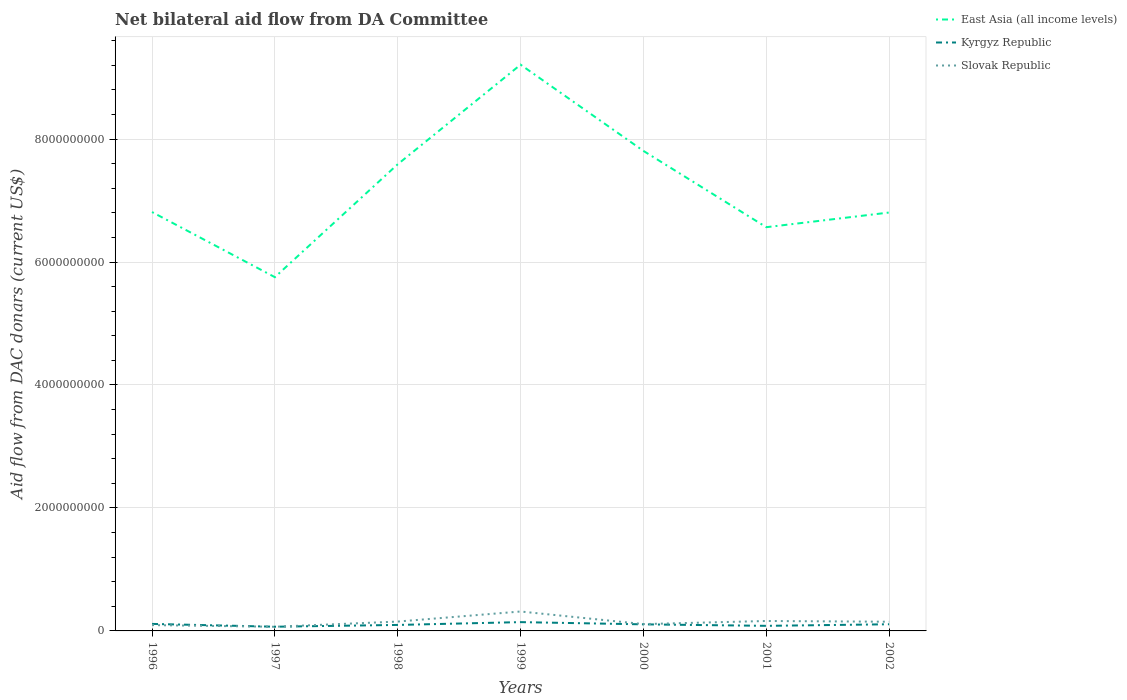How many different coloured lines are there?
Provide a succinct answer. 3. Does the line corresponding to East Asia (all income levels) intersect with the line corresponding to Slovak Republic?
Provide a short and direct response. No. Is the number of lines equal to the number of legend labels?
Your answer should be very brief. Yes. Across all years, what is the maximum aid flow in in East Asia (all income levels)?
Your answer should be very brief. 5.75e+09. In which year was the aid flow in in East Asia (all income levels) maximum?
Provide a succinct answer. 1997. What is the total aid flow in in East Asia (all income levels) in the graph?
Give a very brief answer. 1.06e+09. What is the difference between the highest and the second highest aid flow in in East Asia (all income levels)?
Your answer should be compact. 3.46e+09. Is the aid flow in in Kyrgyz Republic strictly greater than the aid flow in in Slovak Republic over the years?
Your answer should be very brief. No. What is the difference between two consecutive major ticks on the Y-axis?
Provide a succinct answer. 2.00e+09. Are the values on the major ticks of Y-axis written in scientific E-notation?
Offer a very short reply. No. Does the graph contain grids?
Offer a very short reply. Yes. How many legend labels are there?
Your response must be concise. 3. How are the legend labels stacked?
Your answer should be compact. Vertical. What is the title of the graph?
Ensure brevity in your answer.  Net bilateral aid flow from DA Committee. Does "Kyrgyz Republic" appear as one of the legend labels in the graph?
Your answer should be compact. Yes. What is the label or title of the X-axis?
Give a very brief answer. Years. What is the label or title of the Y-axis?
Make the answer very short. Aid flow from DAC donars (current US$). What is the Aid flow from DAC donars (current US$) in East Asia (all income levels) in 1996?
Make the answer very short. 6.81e+09. What is the Aid flow from DAC donars (current US$) in Kyrgyz Republic in 1996?
Offer a terse response. 1.14e+08. What is the Aid flow from DAC donars (current US$) of Slovak Republic in 1996?
Offer a terse response. 9.47e+07. What is the Aid flow from DAC donars (current US$) in East Asia (all income levels) in 1997?
Your answer should be compact. 5.75e+09. What is the Aid flow from DAC donars (current US$) in Kyrgyz Republic in 1997?
Make the answer very short. 6.83e+07. What is the Aid flow from DAC donars (current US$) of Slovak Republic in 1997?
Provide a succinct answer. 6.75e+07. What is the Aid flow from DAC donars (current US$) of East Asia (all income levels) in 1998?
Your answer should be very brief. 7.59e+09. What is the Aid flow from DAC donars (current US$) in Kyrgyz Republic in 1998?
Your answer should be very brief. 9.74e+07. What is the Aid flow from DAC donars (current US$) of Slovak Republic in 1998?
Make the answer very short. 1.52e+08. What is the Aid flow from DAC donars (current US$) in East Asia (all income levels) in 1999?
Provide a short and direct response. 9.21e+09. What is the Aid flow from DAC donars (current US$) of Kyrgyz Republic in 1999?
Provide a short and direct response. 1.43e+08. What is the Aid flow from DAC donars (current US$) of Slovak Republic in 1999?
Provide a short and direct response. 3.16e+08. What is the Aid flow from DAC donars (current US$) of East Asia (all income levels) in 2000?
Your answer should be very brief. 7.81e+09. What is the Aid flow from DAC donars (current US$) of Kyrgyz Republic in 2000?
Keep it short and to the point. 1.07e+08. What is the Aid flow from DAC donars (current US$) in Slovak Republic in 2000?
Your response must be concise. 1.11e+08. What is the Aid flow from DAC donars (current US$) in East Asia (all income levels) in 2001?
Provide a short and direct response. 6.57e+09. What is the Aid flow from DAC donars (current US$) in Kyrgyz Republic in 2001?
Your response must be concise. 8.27e+07. What is the Aid flow from DAC donars (current US$) of Slovak Republic in 2001?
Keep it short and to the point. 1.62e+08. What is the Aid flow from DAC donars (current US$) in East Asia (all income levels) in 2002?
Give a very brief answer. 6.80e+09. What is the Aid flow from DAC donars (current US$) of Kyrgyz Republic in 2002?
Make the answer very short. 1.08e+08. What is the Aid flow from DAC donars (current US$) of Slovak Republic in 2002?
Your response must be concise. 1.49e+08. Across all years, what is the maximum Aid flow from DAC donars (current US$) of East Asia (all income levels)?
Make the answer very short. 9.21e+09. Across all years, what is the maximum Aid flow from DAC donars (current US$) of Kyrgyz Republic?
Give a very brief answer. 1.43e+08. Across all years, what is the maximum Aid flow from DAC donars (current US$) in Slovak Republic?
Your answer should be very brief. 3.16e+08. Across all years, what is the minimum Aid flow from DAC donars (current US$) of East Asia (all income levels)?
Give a very brief answer. 5.75e+09. Across all years, what is the minimum Aid flow from DAC donars (current US$) in Kyrgyz Republic?
Offer a terse response. 6.83e+07. Across all years, what is the minimum Aid flow from DAC donars (current US$) of Slovak Republic?
Ensure brevity in your answer.  6.75e+07. What is the total Aid flow from DAC donars (current US$) in East Asia (all income levels) in the graph?
Give a very brief answer. 5.05e+1. What is the total Aid flow from DAC donars (current US$) in Kyrgyz Republic in the graph?
Give a very brief answer. 7.21e+08. What is the total Aid flow from DAC donars (current US$) in Slovak Republic in the graph?
Your answer should be compact. 1.05e+09. What is the difference between the Aid flow from DAC donars (current US$) of East Asia (all income levels) in 1996 and that in 1997?
Offer a terse response. 1.06e+09. What is the difference between the Aid flow from DAC donars (current US$) of Kyrgyz Republic in 1996 and that in 1997?
Offer a very short reply. 4.58e+07. What is the difference between the Aid flow from DAC donars (current US$) of Slovak Republic in 1996 and that in 1997?
Make the answer very short. 2.72e+07. What is the difference between the Aid flow from DAC donars (current US$) of East Asia (all income levels) in 1996 and that in 1998?
Offer a terse response. -7.77e+08. What is the difference between the Aid flow from DAC donars (current US$) of Kyrgyz Republic in 1996 and that in 1998?
Your answer should be very brief. 1.66e+07. What is the difference between the Aid flow from DAC donars (current US$) in Slovak Republic in 1996 and that in 1998?
Ensure brevity in your answer.  -5.76e+07. What is the difference between the Aid flow from DAC donars (current US$) of East Asia (all income levels) in 1996 and that in 1999?
Offer a very short reply. -2.40e+09. What is the difference between the Aid flow from DAC donars (current US$) in Kyrgyz Republic in 1996 and that in 1999?
Your response must be concise. -2.91e+07. What is the difference between the Aid flow from DAC donars (current US$) of Slovak Republic in 1996 and that in 1999?
Your answer should be compact. -2.21e+08. What is the difference between the Aid flow from DAC donars (current US$) of East Asia (all income levels) in 1996 and that in 2000?
Give a very brief answer. -9.94e+08. What is the difference between the Aid flow from DAC donars (current US$) of Kyrgyz Republic in 1996 and that in 2000?
Give a very brief answer. 7.11e+06. What is the difference between the Aid flow from DAC donars (current US$) of Slovak Republic in 1996 and that in 2000?
Provide a short and direct response. -1.63e+07. What is the difference between the Aid flow from DAC donars (current US$) in East Asia (all income levels) in 1996 and that in 2001?
Keep it short and to the point. 2.47e+08. What is the difference between the Aid flow from DAC donars (current US$) in Kyrgyz Republic in 1996 and that in 2001?
Provide a short and direct response. 3.13e+07. What is the difference between the Aid flow from DAC donars (current US$) of Slovak Republic in 1996 and that in 2001?
Offer a very short reply. -6.70e+07. What is the difference between the Aid flow from DAC donars (current US$) in East Asia (all income levels) in 1996 and that in 2002?
Ensure brevity in your answer.  7.84e+06. What is the difference between the Aid flow from DAC donars (current US$) of Kyrgyz Republic in 1996 and that in 2002?
Offer a very short reply. 5.82e+06. What is the difference between the Aid flow from DAC donars (current US$) of Slovak Republic in 1996 and that in 2002?
Keep it short and to the point. -5.47e+07. What is the difference between the Aid flow from DAC donars (current US$) in East Asia (all income levels) in 1997 and that in 1998?
Provide a succinct answer. -1.84e+09. What is the difference between the Aid flow from DAC donars (current US$) in Kyrgyz Republic in 1997 and that in 1998?
Keep it short and to the point. -2.91e+07. What is the difference between the Aid flow from DAC donars (current US$) in Slovak Republic in 1997 and that in 1998?
Your answer should be very brief. -8.48e+07. What is the difference between the Aid flow from DAC donars (current US$) of East Asia (all income levels) in 1997 and that in 1999?
Your answer should be very brief. -3.46e+09. What is the difference between the Aid flow from DAC donars (current US$) of Kyrgyz Republic in 1997 and that in 1999?
Offer a terse response. -7.48e+07. What is the difference between the Aid flow from DAC donars (current US$) of Slovak Republic in 1997 and that in 1999?
Offer a terse response. -2.48e+08. What is the difference between the Aid flow from DAC donars (current US$) in East Asia (all income levels) in 1997 and that in 2000?
Your answer should be very brief. -2.05e+09. What is the difference between the Aid flow from DAC donars (current US$) in Kyrgyz Republic in 1997 and that in 2000?
Your answer should be very brief. -3.86e+07. What is the difference between the Aid flow from DAC donars (current US$) of Slovak Republic in 1997 and that in 2000?
Provide a short and direct response. -4.35e+07. What is the difference between the Aid flow from DAC donars (current US$) in East Asia (all income levels) in 1997 and that in 2001?
Provide a succinct answer. -8.13e+08. What is the difference between the Aid flow from DAC donars (current US$) in Kyrgyz Republic in 1997 and that in 2001?
Provide a short and direct response. -1.44e+07. What is the difference between the Aid flow from DAC donars (current US$) in Slovak Republic in 1997 and that in 2001?
Ensure brevity in your answer.  -9.42e+07. What is the difference between the Aid flow from DAC donars (current US$) of East Asia (all income levels) in 1997 and that in 2002?
Your answer should be very brief. -1.05e+09. What is the difference between the Aid flow from DAC donars (current US$) of Kyrgyz Republic in 1997 and that in 2002?
Your response must be concise. -3.99e+07. What is the difference between the Aid flow from DAC donars (current US$) in Slovak Republic in 1997 and that in 2002?
Offer a terse response. -8.19e+07. What is the difference between the Aid flow from DAC donars (current US$) in East Asia (all income levels) in 1998 and that in 1999?
Give a very brief answer. -1.62e+09. What is the difference between the Aid flow from DAC donars (current US$) in Kyrgyz Republic in 1998 and that in 1999?
Your answer should be very brief. -4.57e+07. What is the difference between the Aid flow from DAC donars (current US$) in Slovak Republic in 1998 and that in 1999?
Provide a succinct answer. -1.64e+08. What is the difference between the Aid flow from DAC donars (current US$) of East Asia (all income levels) in 1998 and that in 2000?
Your answer should be very brief. -2.17e+08. What is the difference between the Aid flow from DAC donars (current US$) in Kyrgyz Republic in 1998 and that in 2000?
Ensure brevity in your answer.  -9.52e+06. What is the difference between the Aid flow from DAC donars (current US$) of Slovak Republic in 1998 and that in 2000?
Your answer should be compact. 4.13e+07. What is the difference between the Aid flow from DAC donars (current US$) in East Asia (all income levels) in 1998 and that in 2001?
Offer a terse response. 1.02e+09. What is the difference between the Aid flow from DAC donars (current US$) in Kyrgyz Republic in 1998 and that in 2001?
Offer a terse response. 1.47e+07. What is the difference between the Aid flow from DAC donars (current US$) in Slovak Republic in 1998 and that in 2001?
Make the answer very short. -9.41e+06. What is the difference between the Aid flow from DAC donars (current US$) in East Asia (all income levels) in 1998 and that in 2002?
Offer a very short reply. 7.85e+08. What is the difference between the Aid flow from DAC donars (current US$) in Kyrgyz Republic in 1998 and that in 2002?
Keep it short and to the point. -1.08e+07. What is the difference between the Aid flow from DAC donars (current US$) of Slovak Republic in 1998 and that in 2002?
Offer a very short reply. 2.87e+06. What is the difference between the Aid flow from DAC donars (current US$) of East Asia (all income levels) in 1999 and that in 2000?
Your answer should be compact. 1.40e+09. What is the difference between the Aid flow from DAC donars (current US$) of Kyrgyz Republic in 1999 and that in 2000?
Ensure brevity in your answer.  3.62e+07. What is the difference between the Aid flow from DAC donars (current US$) of Slovak Republic in 1999 and that in 2000?
Provide a short and direct response. 2.05e+08. What is the difference between the Aid flow from DAC donars (current US$) in East Asia (all income levels) in 1999 and that in 2001?
Your answer should be very brief. 2.64e+09. What is the difference between the Aid flow from DAC donars (current US$) of Kyrgyz Republic in 1999 and that in 2001?
Your answer should be compact. 6.04e+07. What is the difference between the Aid flow from DAC donars (current US$) in Slovak Republic in 1999 and that in 2001?
Your answer should be very brief. 1.54e+08. What is the difference between the Aid flow from DAC donars (current US$) in East Asia (all income levels) in 1999 and that in 2002?
Your response must be concise. 2.40e+09. What is the difference between the Aid flow from DAC donars (current US$) in Kyrgyz Republic in 1999 and that in 2002?
Offer a very short reply. 3.49e+07. What is the difference between the Aid flow from DAC donars (current US$) in Slovak Republic in 1999 and that in 2002?
Give a very brief answer. 1.66e+08. What is the difference between the Aid flow from DAC donars (current US$) of East Asia (all income levels) in 2000 and that in 2001?
Your response must be concise. 1.24e+09. What is the difference between the Aid flow from DAC donars (current US$) of Kyrgyz Republic in 2000 and that in 2001?
Provide a succinct answer. 2.42e+07. What is the difference between the Aid flow from DAC donars (current US$) in Slovak Republic in 2000 and that in 2001?
Your response must be concise. -5.07e+07. What is the difference between the Aid flow from DAC donars (current US$) of East Asia (all income levels) in 2000 and that in 2002?
Keep it short and to the point. 1.00e+09. What is the difference between the Aid flow from DAC donars (current US$) of Kyrgyz Republic in 2000 and that in 2002?
Keep it short and to the point. -1.29e+06. What is the difference between the Aid flow from DAC donars (current US$) in Slovak Republic in 2000 and that in 2002?
Make the answer very short. -3.84e+07. What is the difference between the Aid flow from DAC donars (current US$) of East Asia (all income levels) in 2001 and that in 2002?
Provide a succinct answer. -2.39e+08. What is the difference between the Aid flow from DAC donars (current US$) of Kyrgyz Republic in 2001 and that in 2002?
Ensure brevity in your answer.  -2.55e+07. What is the difference between the Aid flow from DAC donars (current US$) of Slovak Republic in 2001 and that in 2002?
Keep it short and to the point. 1.23e+07. What is the difference between the Aid flow from DAC donars (current US$) of East Asia (all income levels) in 1996 and the Aid flow from DAC donars (current US$) of Kyrgyz Republic in 1997?
Keep it short and to the point. 6.74e+09. What is the difference between the Aid flow from DAC donars (current US$) of East Asia (all income levels) in 1996 and the Aid flow from DAC donars (current US$) of Slovak Republic in 1997?
Ensure brevity in your answer.  6.75e+09. What is the difference between the Aid flow from DAC donars (current US$) in Kyrgyz Republic in 1996 and the Aid flow from DAC donars (current US$) in Slovak Republic in 1997?
Give a very brief answer. 4.66e+07. What is the difference between the Aid flow from DAC donars (current US$) of East Asia (all income levels) in 1996 and the Aid flow from DAC donars (current US$) of Kyrgyz Republic in 1998?
Make the answer very short. 6.72e+09. What is the difference between the Aid flow from DAC donars (current US$) of East Asia (all income levels) in 1996 and the Aid flow from DAC donars (current US$) of Slovak Republic in 1998?
Give a very brief answer. 6.66e+09. What is the difference between the Aid flow from DAC donars (current US$) of Kyrgyz Republic in 1996 and the Aid flow from DAC donars (current US$) of Slovak Republic in 1998?
Your answer should be very brief. -3.82e+07. What is the difference between the Aid flow from DAC donars (current US$) of East Asia (all income levels) in 1996 and the Aid flow from DAC donars (current US$) of Kyrgyz Republic in 1999?
Provide a succinct answer. 6.67e+09. What is the difference between the Aid flow from DAC donars (current US$) in East Asia (all income levels) in 1996 and the Aid flow from DAC donars (current US$) in Slovak Republic in 1999?
Provide a short and direct response. 6.50e+09. What is the difference between the Aid flow from DAC donars (current US$) of Kyrgyz Republic in 1996 and the Aid flow from DAC donars (current US$) of Slovak Republic in 1999?
Provide a succinct answer. -2.02e+08. What is the difference between the Aid flow from DAC donars (current US$) in East Asia (all income levels) in 1996 and the Aid flow from DAC donars (current US$) in Kyrgyz Republic in 2000?
Offer a very short reply. 6.71e+09. What is the difference between the Aid flow from DAC donars (current US$) in East Asia (all income levels) in 1996 and the Aid flow from DAC donars (current US$) in Slovak Republic in 2000?
Your answer should be very brief. 6.70e+09. What is the difference between the Aid flow from DAC donars (current US$) of Kyrgyz Republic in 1996 and the Aid flow from DAC donars (current US$) of Slovak Republic in 2000?
Offer a terse response. 3.05e+06. What is the difference between the Aid flow from DAC donars (current US$) in East Asia (all income levels) in 1996 and the Aid flow from DAC donars (current US$) in Kyrgyz Republic in 2001?
Make the answer very short. 6.73e+09. What is the difference between the Aid flow from DAC donars (current US$) in East Asia (all income levels) in 1996 and the Aid flow from DAC donars (current US$) in Slovak Republic in 2001?
Your response must be concise. 6.65e+09. What is the difference between the Aid flow from DAC donars (current US$) of Kyrgyz Republic in 1996 and the Aid flow from DAC donars (current US$) of Slovak Republic in 2001?
Keep it short and to the point. -4.76e+07. What is the difference between the Aid flow from DAC donars (current US$) in East Asia (all income levels) in 1996 and the Aid flow from DAC donars (current US$) in Kyrgyz Republic in 2002?
Provide a short and direct response. 6.70e+09. What is the difference between the Aid flow from DAC donars (current US$) in East Asia (all income levels) in 1996 and the Aid flow from DAC donars (current US$) in Slovak Republic in 2002?
Provide a succinct answer. 6.66e+09. What is the difference between the Aid flow from DAC donars (current US$) of Kyrgyz Republic in 1996 and the Aid flow from DAC donars (current US$) of Slovak Republic in 2002?
Ensure brevity in your answer.  -3.54e+07. What is the difference between the Aid flow from DAC donars (current US$) of East Asia (all income levels) in 1997 and the Aid flow from DAC donars (current US$) of Kyrgyz Republic in 1998?
Your response must be concise. 5.66e+09. What is the difference between the Aid flow from DAC donars (current US$) in East Asia (all income levels) in 1997 and the Aid flow from DAC donars (current US$) in Slovak Republic in 1998?
Your answer should be very brief. 5.60e+09. What is the difference between the Aid flow from DAC donars (current US$) in Kyrgyz Republic in 1997 and the Aid flow from DAC donars (current US$) in Slovak Republic in 1998?
Your answer should be compact. -8.40e+07. What is the difference between the Aid flow from DAC donars (current US$) in East Asia (all income levels) in 1997 and the Aid flow from DAC donars (current US$) in Kyrgyz Republic in 1999?
Offer a very short reply. 5.61e+09. What is the difference between the Aid flow from DAC donars (current US$) in East Asia (all income levels) in 1997 and the Aid flow from DAC donars (current US$) in Slovak Republic in 1999?
Give a very brief answer. 5.44e+09. What is the difference between the Aid flow from DAC donars (current US$) of Kyrgyz Republic in 1997 and the Aid flow from DAC donars (current US$) of Slovak Republic in 1999?
Ensure brevity in your answer.  -2.48e+08. What is the difference between the Aid flow from DAC donars (current US$) of East Asia (all income levels) in 1997 and the Aid flow from DAC donars (current US$) of Kyrgyz Republic in 2000?
Ensure brevity in your answer.  5.65e+09. What is the difference between the Aid flow from DAC donars (current US$) of East Asia (all income levels) in 1997 and the Aid flow from DAC donars (current US$) of Slovak Republic in 2000?
Give a very brief answer. 5.64e+09. What is the difference between the Aid flow from DAC donars (current US$) of Kyrgyz Republic in 1997 and the Aid flow from DAC donars (current US$) of Slovak Republic in 2000?
Give a very brief answer. -4.27e+07. What is the difference between the Aid flow from DAC donars (current US$) of East Asia (all income levels) in 1997 and the Aid flow from DAC donars (current US$) of Kyrgyz Republic in 2001?
Your answer should be compact. 5.67e+09. What is the difference between the Aid flow from DAC donars (current US$) in East Asia (all income levels) in 1997 and the Aid flow from DAC donars (current US$) in Slovak Republic in 2001?
Offer a very short reply. 5.59e+09. What is the difference between the Aid flow from DAC donars (current US$) of Kyrgyz Republic in 1997 and the Aid flow from DAC donars (current US$) of Slovak Republic in 2001?
Provide a succinct answer. -9.34e+07. What is the difference between the Aid flow from DAC donars (current US$) in East Asia (all income levels) in 1997 and the Aid flow from DAC donars (current US$) in Kyrgyz Republic in 2002?
Make the answer very short. 5.65e+09. What is the difference between the Aid flow from DAC donars (current US$) of East Asia (all income levels) in 1997 and the Aid flow from DAC donars (current US$) of Slovak Republic in 2002?
Give a very brief answer. 5.60e+09. What is the difference between the Aid flow from DAC donars (current US$) of Kyrgyz Republic in 1997 and the Aid flow from DAC donars (current US$) of Slovak Republic in 2002?
Your answer should be compact. -8.11e+07. What is the difference between the Aid flow from DAC donars (current US$) of East Asia (all income levels) in 1998 and the Aid flow from DAC donars (current US$) of Kyrgyz Republic in 1999?
Provide a succinct answer. 7.45e+09. What is the difference between the Aid flow from DAC donars (current US$) of East Asia (all income levels) in 1998 and the Aid flow from DAC donars (current US$) of Slovak Republic in 1999?
Your answer should be very brief. 7.27e+09. What is the difference between the Aid flow from DAC donars (current US$) in Kyrgyz Republic in 1998 and the Aid flow from DAC donars (current US$) in Slovak Republic in 1999?
Offer a terse response. -2.18e+08. What is the difference between the Aid flow from DAC donars (current US$) in East Asia (all income levels) in 1998 and the Aid flow from DAC donars (current US$) in Kyrgyz Republic in 2000?
Ensure brevity in your answer.  7.48e+09. What is the difference between the Aid flow from DAC donars (current US$) of East Asia (all income levels) in 1998 and the Aid flow from DAC donars (current US$) of Slovak Republic in 2000?
Give a very brief answer. 7.48e+09. What is the difference between the Aid flow from DAC donars (current US$) in Kyrgyz Republic in 1998 and the Aid flow from DAC donars (current US$) in Slovak Republic in 2000?
Your answer should be very brief. -1.36e+07. What is the difference between the Aid flow from DAC donars (current US$) of East Asia (all income levels) in 1998 and the Aid flow from DAC donars (current US$) of Kyrgyz Republic in 2001?
Give a very brief answer. 7.51e+09. What is the difference between the Aid flow from DAC donars (current US$) of East Asia (all income levels) in 1998 and the Aid flow from DAC donars (current US$) of Slovak Republic in 2001?
Your answer should be very brief. 7.43e+09. What is the difference between the Aid flow from DAC donars (current US$) of Kyrgyz Republic in 1998 and the Aid flow from DAC donars (current US$) of Slovak Republic in 2001?
Your response must be concise. -6.43e+07. What is the difference between the Aid flow from DAC donars (current US$) in East Asia (all income levels) in 1998 and the Aid flow from DAC donars (current US$) in Kyrgyz Republic in 2002?
Provide a succinct answer. 7.48e+09. What is the difference between the Aid flow from DAC donars (current US$) of East Asia (all income levels) in 1998 and the Aid flow from DAC donars (current US$) of Slovak Republic in 2002?
Give a very brief answer. 7.44e+09. What is the difference between the Aid flow from DAC donars (current US$) in Kyrgyz Republic in 1998 and the Aid flow from DAC donars (current US$) in Slovak Republic in 2002?
Ensure brevity in your answer.  -5.20e+07. What is the difference between the Aid flow from DAC donars (current US$) of East Asia (all income levels) in 1999 and the Aid flow from DAC donars (current US$) of Kyrgyz Republic in 2000?
Keep it short and to the point. 9.10e+09. What is the difference between the Aid flow from DAC donars (current US$) of East Asia (all income levels) in 1999 and the Aid flow from DAC donars (current US$) of Slovak Republic in 2000?
Provide a succinct answer. 9.10e+09. What is the difference between the Aid flow from DAC donars (current US$) in Kyrgyz Republic in 1999 and the Aid flow from DAC donars (current US$) in Slovak Republic in 2000?
Your answer should be compact. 3.21e+07. What is the difference between the Aid flow from DAC donars (current US$) of East Asia (all income levels) in 1999 and the Aid flow from DAC donars (current US$) of Kyrgyz Republic in 2001?
Provide a succinct answer. 9.13e+09. What is the difference between the Aid flow from DAC donars (current US$) of East Asia (all income levels) in 1999 and the Aid flow from DAC donars (current US$) of Slovak Republic in 2001?
Your answer should be compact. 9.05e+09. What is the difference between the Aid flow from DAC donars (current US$) in Kyrgyz Republic in 1999 and the Aid flow from DAC donars (current US$) in Slovak Republic in 2001?
Ensure brevity in your answer.  -1.86e+07. What is the difference between the Aid flow from DAC donars (current US$) in East Asia (all income levels) in 1999 and the Aid flow from DAC donars (current US$) in Kyrgyz Republic in 2002?
Your answer should be compact. 9.10e+09. What is the difference between the Aid flow from DAC donars (current US$) in East Asia (all income levels) in 1999 and the Aid flow from DAC donars (current US$) in Slovak Republic in 2002?
Your answer should be very brief. 9.06e+09. What is the difference between the Aid flow from DAC donars (current US$) in Kyrgyz Republic in 1999 and the Aid flow from DAC donars (current US$) in Slovak Republic in 2002?
Give a very brief answer. -6.27e+06. What is the difference between the Aid flow from DAC donars (current US$) of East Asia (all income levels) in 2000 and the Aid flow from DAC donars (current US$) of Kyrgyz Republic in 2001?
Offer a very short reply. 7.72e+09. What is the difference between the Aid flow from DAC donars (current US$) of East Asia (all income levels) in 2000 and the Aid flow from DAC donars (current US$) of Slovak Republic in 2001?
Give a very brief answer. 7.65e+09. What is the difference between the Aid flow from DAC donars (current US$) in Kyrgyz Republic in 2000 and the Aid flow from DAC donars (current US$) in Slovak Republic in 2001?
Offer a very short reply. -5.48e+07. What is the difference between the Aid flow from DAC donars (current US$) in East Asia (all income levels) in 2000 and the Aid flow from DAC donars (current US$) in Kyrgyz Republic in 2002?
Your response must be concise. 7.70e+09. What is the difference between the Aid flow from DAC donars (current US$) in East Asia (all income levels) in 2000 and the Aid flow from DAC donars (current US$) in Slovak Republic in 2002?
Offer a very short reply. 7.66e+09. What is the difference between the Aid flow from DAC donars (current US$) in Kyrgyz Republic in 2000 and the Aid flow from DAC donars (current US$) in Slovak Republic in 2002?
Provide a short and direct response. -4.25e+07. What is the difference between the Aid flow from DAC donars (current US$) of East Asia (all income levels) in 2001 and the Aid flow from DAC donars (current US$) of Kyrgyz Republic in 2002?
Provide a short and direct response. 6.46e+09. What is the difference between the Aid flow from DAC donars (current US$) of East Asia (all income levels) in 2001 and the Aid flow from DAC donars (current US$) of Slovak Republic in 2002?
Offer a very short reply. 6.42e+09. What is the difference between the Aid flow from DAC donars (current US$) in Kyrgyz Republic in 2001 and the Aid flow from DAC donars (current US$) in Slovak Republic in 2002?
Offer a very short reply. -6.67e+07. What is the average Aid flow from DAC donars (current US$) in East Asia (all income levels) per year?
Your answer should be very brief. 7.22e+09. What is the average Aid flow from DAC donars (current US$) in Kyrgyz Republic per year?
Your response must be concise. 1.03e+08. What is the average Aid flow from DAC donars (current US$) in Slovak Republic per year?
Make the answer very short. 1.50e+08. In the year 1996, what is the difference between the Aid flow from DAC donars (current US$) in East Asia (all income levels) and Aid flow from DAC donars (current US$) in Kyrgyz Republic?
Provide a succinct answer. 6.70e+09. In the year 1996, what is the difference between the Aid flow from DAC donars (current US$) in East Asia (all income levels) and Aid flow from DAC donars (current US$) in Slovak Republic?
Your answer should be compact. 6.72e+09. In the year 1996, what is the difference between the Aid flow from DAC donars (current US$) in Kyrgyz Republic and Aid flow from DAC donars (current US$) in Slovak Republic?
Provide a succinct answer. 1.93e+07. In the year 1997, what is the difference between the Aid flow from DAC donars (current US$) of East Asia (all income levels) and Aid flow from DAC donars (current US$) of Kyrgyz Republic?
Make the answer very short. 5.69e+09. In the year 1997, what is the difference between the Aid flow from DAC donars (current US$) of East Asia (all income levels) and Aid flow from DAC donars (current US$) of Slovak Republic?
Provide a short and direct response. 5.69e+09. In the year 1997, what is the difference between the Aid flow from DAC donars (current US$) of Kyrgyz Republic and Aid flow from DAC donars (current US$) of Slovak Republic?
Ensure brevity in your answer.  8.10e+05. In the year 1998, what is the difference between the Aid flow from DAC donars (current US$) of East Asia (all income levels) and Aid flow from DAC donars (current US$) of Kyrgyz Republic?
Make the answer very short. 7.49e+09. In the year 1998, what is the difference between the Aid flow from DAC donars (current US$) of East Asia (all income levels) and Aid flow from DAC donars (current US$) of Slovak Republic?
Your answer should be compact. 7.44e+09. In the year 1998, what is the difference between the Aid flow from DAC donars (current US$) of Kyrgyz Republic and Aid flow from DAC donars (current US$) of Slovak Republic?
Your answer should be very brief. -5.49e+07. In the year 1999, what is the difference between the Aid flow from DAC donars (current US$) of East Asia (all income levels) and Aid flow from DAC donars (current US$) of Kyrgyz Republic?
Make the answer very short. 9.07e+09. In the year 1999, what is the difference between the Aid flow from DAC donars (current US$) of East Asia (all income levels) and Aid flow from DAC donars (current US$) of Slovak Republic?
Give a very brief answer. 8.89e+09. In the year 1999, what is the difference between the Aid flow from DAC donars (current US$) of Kyrgyz Republic and Aid flow from DAC donars (current US$) of Slovak Republic?
Your answer should be compact. -1.73e+08. In the year 2000, what is the difference between the Aid flow from DAC donars (current US$) in East Asia (all income levels) and Aid flow from DAC donars (current US$) in Kyrgyz Republic?
Offer a terse response. 7.70e+09. In the year 2000, what is the difference between the Aid flow from DAC donars (current US$) of East Asia (all income levels) and Aid flow from DAC donars (current US$) of Slovak Republic?
Ensure brevity in your answer.  7.70e+09. In the year 2000, what is the difference between the Aid flow from DAC donars (current US$) of Kyrgyz Republic and Aid flow from DAC donars (current US$) of Slovak Republic?
Provide a short and direct response. -4.06e+06. In the year 2001, what is the difference between the Aid flow from DAC donars (current US$) in East Asia (all income levels) and Aid flow from DAC donars (current US$) in Kyrgyz Republic?
Your answer should be very brief. 6.48e+09. In the year 2001, what is the difference between the Aid flow from DAC donars (current US$) of East Asia (all income levels) and Aid flow from DAC donars (current US$) of Slovak Republic?
Provide a succinct answer. 6.40e+09. In the year 2001, what is the difference between the Aid flow from DAC donars (current US$) in Kyrgyz Republic and Aid flow from DAC donars (current US$) in Slovak Republic?
Your answer should be compact. -7.90e+07. In the year 2002, what is the difference between the Aid flow from DAC donars (current US$) in East Asia (all income levels) and Aid flow from DAC donars (current US$) in Kyrgyz Republic?
Provide a short and direct response. 6.70e+09. In the year 2002, what is the difference between the Aid flow from DAC donars (current US$) of East Asia (all income levels) and Aid flow from DAC donars (current US$) of Slovak Republic?
Offer a very short reply. 6.66e+09. In the year 2002, what is the difference between the Aid flow from DAC donars (current US$) of Kyrgyz Republic and Aid flow from DAC donars (current US$) of Slovak Republic?
Offer a very short reply. -4.12e+07. What is the ratio of the Aid flow from DAC donars (current US$) of East Asia (all income levels) in 1996 to that in 1997?
Your answer should be compact. 1.18. What is the ratio of the Aid flow from DAC donars (current US$) of Kyrgyz Republic in 1996 to that in 1997?
Make the answer very short. 1.67. What is the ratio of the Aid flow from DAC donars (current US$) in Slovak Republic in 1996 to that in 1997?
Keep it short and to the point. 1.4. What is the ratio of the Aid flow from DAC donars (current US$) of East Asia (all income levels) in 1996 to that in 1998?
Give a very brief answer. 0.9. What is the ratio of the Aid flow from DAC donars (current US$) in Kyrgyz Republic in 1996 to that in 1998?
Offer a very short reply. 1.17. What is the ratio of the Aid flow from DAC donars (current US$) of Slovak Republic in 1996 to that in 1998?
Give a very brief answer. 0.62. What is the ratio of the Aid flow from DAC donars (current US$) of East Asia (all income levels) in 1996 to that in 1999?
Offer a very short reply. 0.74. What is the ratio of the Aid flow from DAC donars (current US$) in Kyrgyz Republic in 1996 to that in 1999?
Make the answer very short. 0.8. What is the ratio of the Aid flow from DAC donars (current US$) of Slovak Republic in 1996 to that in 1999?
Offer a terse response. 0.3. What is the ratio of the Aid flow from DAC donars (current US$) in East Asia (all income levels) in 1996 to that in 2000?
Provide a short and direct response. 0.87. What is the ratio of the Aid flow from DAC donars (current US$) in Kyrgyz Republic in 1996 to that in 2000?
Keep it short and to the point. 1.07. What is the ratio of the Aid flow from DAC donars (current US$) of Slovak Republic in 1996 to that in 2000?
Provide a succinct answer. 0.85. What is the ratio of the Aid flow from DAC donars (current US$) in East Asia (all income levels) in 1996 to that in 2001?
Provide a succinct answer. 1.04. What is the ratio of the Aid flow from DAC donars (current US$) of Kyrgyz Republic in 1996 to that in 2001?
Your answer should be compact. 1.38. What is the ratio of the Aid flow from DAC donars (current US$) in Slovak Republic in 1996 to that in 2001?
Your response must be concise. 0.59. What is the ratio of the Aid flow from DAC donars (current US$) of East Asia (all income levels) in 1996 to that in 2002?
Provide a short and direct response. 1. What is the ratio of the Aid flow from DAC donars (current US$) of Kyrgyz Republic in 1996 to that in 2002?
Keep it short and to the point. 1.05. What is the ratio of the Aid flow from DAC donars (current US$) of Slovak Republic in 1996 to that in 2002?
Offer a terse response. 0.63. What is the ratio of the Aid flow from DAC donars (current US$) of East Asia (all income levels) in 1997 to that in 1998?
Your response must be concise. 0.76. What is the ratio of the Aid flow from DAC donars (current US$) of Kyrgyz Republic in 1997 to that in 1998?
Your answer should be compact. 0.7. What is the ratio of the Aid flow from DAC donars (current US$) in Slovak Republic in 1997 to that in 1998?
Make the answer very short. 0.44. What is the ratio of the Aid flow from DAC donars (current US$) in East Asia (all income levels) in 1997 to that in 1999?
Keep it short and to the point. 0.62. What is the ratio of the Aid flow from DAC donars (current US$) in Kyrgyz Republic in 1997 to that in 1999?
Offer a very short reply. 0.48. What is the ratio of the Aid flow from DAC donars (current US$) in Slovak Republic in 1997 to that in 1999?
Ensure brevity in your answer.  0.21. What is the ratio of the Aid flow from DAC donars (current US$) of East Asia (all income levels) in 1997 to that in 2000?
Give a very brief answer. 0.74. What is the ratio of the Aid flow from DAC donars (current US$) in Kyrgyz Republic in 1997 to that in 2000?
Provide a succinct answer. 0.64. What is the ratio of the Aid flow from DAC donars (current US$) in Slovak Republic in 1997 to that in 2000?
Make the answer very short. 0.61. What is the ratio of the Aid flow from DAC donars (current US$) in East Asia (all income levels) in 1997 to that in 2001?
Ensure brevity in your answer.  0.88. What is the ratio of the Aid flow from DAC donars (current US$) of Kyrgyz Republic in 1997 to that in 2001?
Ensure brevity in your answer.  0.83. What is the ratio of the Aid flow from DAC donars (current US$) in Slovak Republic in 1997 to that in 2001?
Your response must be concise. 0.42. What is the ratio of the Aid flow from DAC donars (current US$) of East Asia (all income levels) in 1997 to that in 2002?
Provide a short and direct response. 0.85. What is the ratio of the Aid flow from DAC donars (current US$) in Kyrgyz Republic in 1997 to that in 2002?
Ensure brevity in your answer.  0.63. What is the ratio of the Aid flow from DAC donars (current US$) of Slovak Republic in 1997 to that in 2002?
Provide a succinct answer. 0.45. What is the ratio of the Aid flow from DAC donars (current US$) in East Asia (all income levels) in 1998 to that in 1999?
Provide a short and direct response. 0.82. What is the ratio of the Aid flow from DAC donars (current US$) of Kyrgyz Republic in 1998 to that in 1999?
Make the answer very short. 0.68. What is the ratio of the Aid flow from DAC donars (current US$) in Slovak Republic in 1998 to that in 1999?
Give a very brief answer. 0.48. What is the ratio of the Aid flow from DAC donars (current US$) of East Asia (all income levels) in 1998 to that in 2000?
Your answer should be compact. 0.97. What is the ratio of the Aid flow from DAC donars (current US$) of Kyrgyz Republic in 1998 to that in 2000?
Offer a terse response. 0.91. What is the ratio of the Aid flow from DAC donars (current US$) of Slovak Republic in 1998 to that in 2000?
Provide a short and direct response. 1.37. What is the ratio of the Aid flow from DAC donars (current US$) in East Asia (all income levels) in 1998 to that in 2001?
Offer a very short reply. 1.16. What is the ratio of the Aid flow from DAC donars (current US$) of Kyrgyz Republic in 1998 to that in 2001?
Provide a short and direct response. 1.18. What is the ratio of the Aid flow from DAC donars (current US$) in Slovak Republic in 1998 to that in 2001?
Keep it short and to the point. 0.94. What is the ratio of the Aid flow from DAC donars (current US$) in East Asia (all income levels) in 1998 to that in 2002?
Offer a very short reply. 1.12. What is the ratio of the Aid flow from DAC donars (current US$) of Kyrgyz Republic in 1998 to that in 2002?
Provide a short and direct response. 0.9. What is the ratio of the Aid flow from DAC donars (current US$) of Slovak Republic in 1998 to that in 2002?
Provide a short and direct response. 1.02. What is the ratio of the Aid flow from DAC donars (current US$) in East Asia (all income levels) in 1999 to that in 2000?
Provide a short and direct response. 1.18. What is the ratio of the Aid flow from DAC donars (current US$) of Kyrgyz Republic in 1999 to that in 2000?
Give a very brief answer. 1.34. What is the ratio of the Aid flow from DAC donars (current US$) of Slovak Republic in 1999 to that in 2000?
Keep it short and to the point. 2.85. What is the ratio of the Aid flow from DAC donars (current US$) in East Asia (all income levels) in 1999 to that in 2001?
Keep it short and to the point. 1.4. What is the ratio of the Aid flow from DAC donars (current US$) of Kyrgyz Republic in 1999 to that in 2001?
Your answer should be compact. 1.73. What is the ratio of the Aid flow from DAC donars (current US$) in Slovak Republic in 1999 to that in 2001?
Make the answer very short. 1.95. What is the ratio of the Aid flow from DAC donars (current US$) of East Asia (all income levels) in 1999 to that in 2002?
Keep it short and to the point. 1.35. What is the ratio of the Aid flow from DAC donars (current US$) in Kyrgyz Republic in 1999 to that in 2002?
Your answer should be compact. 1.32. What is the ratio of the Aid flow from DAC donars (current US$) in Slovak Republic in 1999 to that in 2002?
Make the answer very short. 2.11. What is the ratio of the Aid flow from DAC donars (current US$) in East Asia (all income levels) in 2000 to that in 2001?
Provide a short and direct response. 1.19. What is the ratio of the Aid flow from DAC donars (current US$) of Kyrgyz Republic in 2000 to that in 2001?
Your answer should be very brief. 1.29. What is the ratio of the Aid flow from DAC donars (current US$) of Slovak Republic in 2000 to that in 2001?
Keep it short and to the point. 0.69. What is the ratio of the Aid flow from DAC donars (current US$) of East Asia (all income levels) in 2000 to that in 2002?
Provide a short and direct response. 1.15. What is the ratio of the Aid flow from DAC donars (current US$) in Slovak Republic in 2000 to that in 2002?
Make the answer very short. 0.74. What is the ratio of the Aid flow from DAC donars (current US$) of East Asia (all income levels) in 2001 to that in 2002?
Your answer should be compact. 0.96. What is the ratio of the Aid flow from DAC donars (current US$) in Kyrgyz Republic in 2001 to that in 2002?
Ensure brevity in your answer.  0.76. What is the ratio of the Aid flow from DAC donars (current US$) of Slovak Republic in 2001 to that in 2002?
Provide a succinct answer. 1.08. What is the difference between the highest and the second highest Aid flow from DAC donars (current US$) of East Asia (all income levels)?
Your answer should be compact. 1.40e+09. What is the difference between the highest and the second highest Aid flow from DAC donars (current US$) of Kyrgyz Republic?
Provide a succinct answer. 2.91e+07. What is the difference between the highest and the second highest Aid flow from DAC donars (current US$) of Slovak Republic?
Give a very brief answer. 1.54e+08. What is the difference between the highest and the lowest Aid flow from DAC donars (current US$) in East Asia (all income levels)?
Make the answer very short. 3.46e+09. What is the difference between the highest and the lowest Aid flow from DAC donars (current US$) in Kyrgyz Republic?
Keep it short and to the point. 7.48e+07. What is the difference between the highest and the lowest Aid flow from DAC donars (current US$) in Slovak Republic?
Keep it short and to the point. 2.48e+08. 